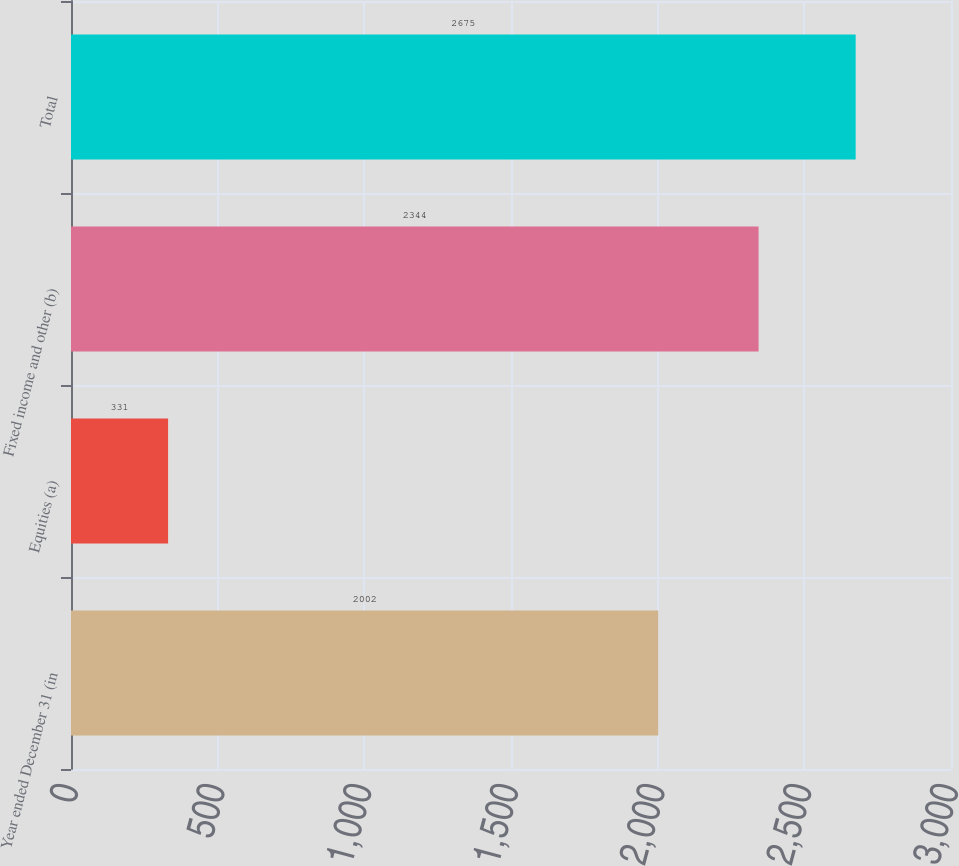Convert chart to OTSL. <chart><loc_0><loc_0><loc_500><loc_500><bar_chart><fcel>Year ended December 31 (in<fcel>Equities (a)<fcel>Fixed income and other (b)<fcel>Total<nl><fcel>2002<fcel>331<fcel>2344<fcel>2675<nl></chart> 